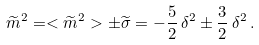<formula> <loc_0><loc_0><loc_500><loc_500>\widetilde { m } ^ { 2 } = < \widetilde { m } ^ { 2 } > \pm \widetilde { \sigma } = - \frac { 5 } { 2 } \, \delta ^ { 2 } \pm \frac { 3 } { 2 } \, \delta ^ { 2 } \, .</formula> 